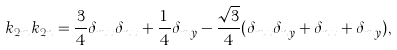<formula> <loc_0><loc_0><loc_500><loc_500>k _ { 2 m } k _ { 2 n } = \frac { 3 } { 4 } \delta _ { m x } \delta _ { n x } + \frac { 1 } { 4 } \delta _ { m y } - \frac { \sqrt { 3 } } { 4 } ( \delta _ { m x } \delta _ { n y } + \delta _ { n x } + \delta _ { m y } ) ,</formula> 